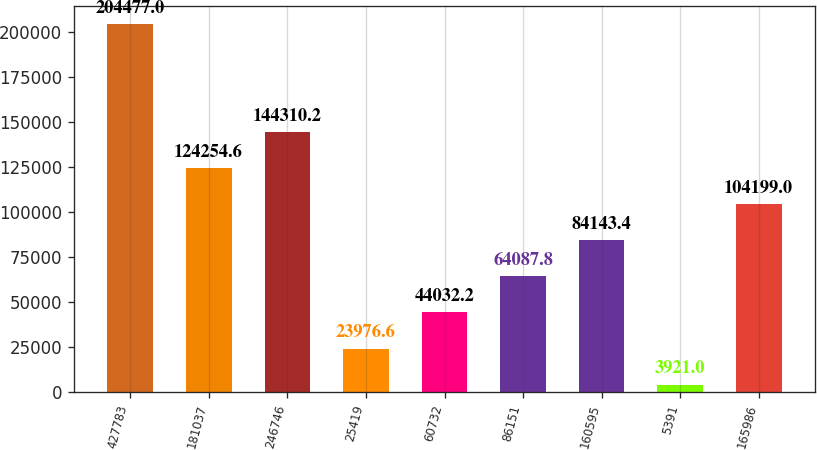<chart> <loc_0><loc_0><loc_500><loc_500><bar_chart><fcel>427783<fcel>181037<fcel>246746<fcel>25419<fcel>60732<fcel>86151<fcel>160595<fcel>5391<fcel>165986<nl><fcel>204477<fcel>124255<fcel>144310<fcel>23976.6<fcel>44032.2<fcel>64087.8<fcel>84143.4<fcel>3921<fcel>104199<nl></chart> 